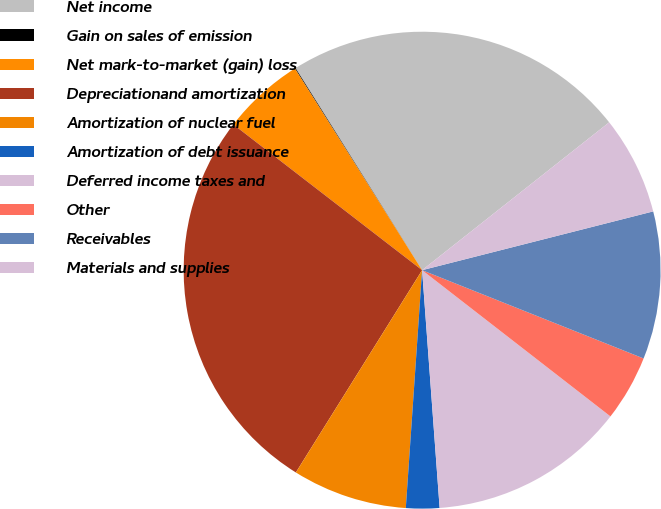Convert chart. <chart><loc_0><loc_0><loc_500><loc_500><pie_chart><fcel>Net income<fcel>Gain on sales of emission<fcel>Net mark-to-market (gain) loss<fcel>Depreciationand amortization<fcel>Amortization of nuclear fuel<fcel>Amortization of debt issuance<fcel>Deferred income taxes and<fcel>Other<fcel>Receivables<fcel>Materials and supplies<nl><fcel>23.26%<fcel>0.05%<fcel>5.58%<fcel>26.58%<fcel>7.79%<fcel>2.26%<fcel>13.32%<fcel>4.47%<fcel>10.0%<fcel>6.68%<nl></chart> 